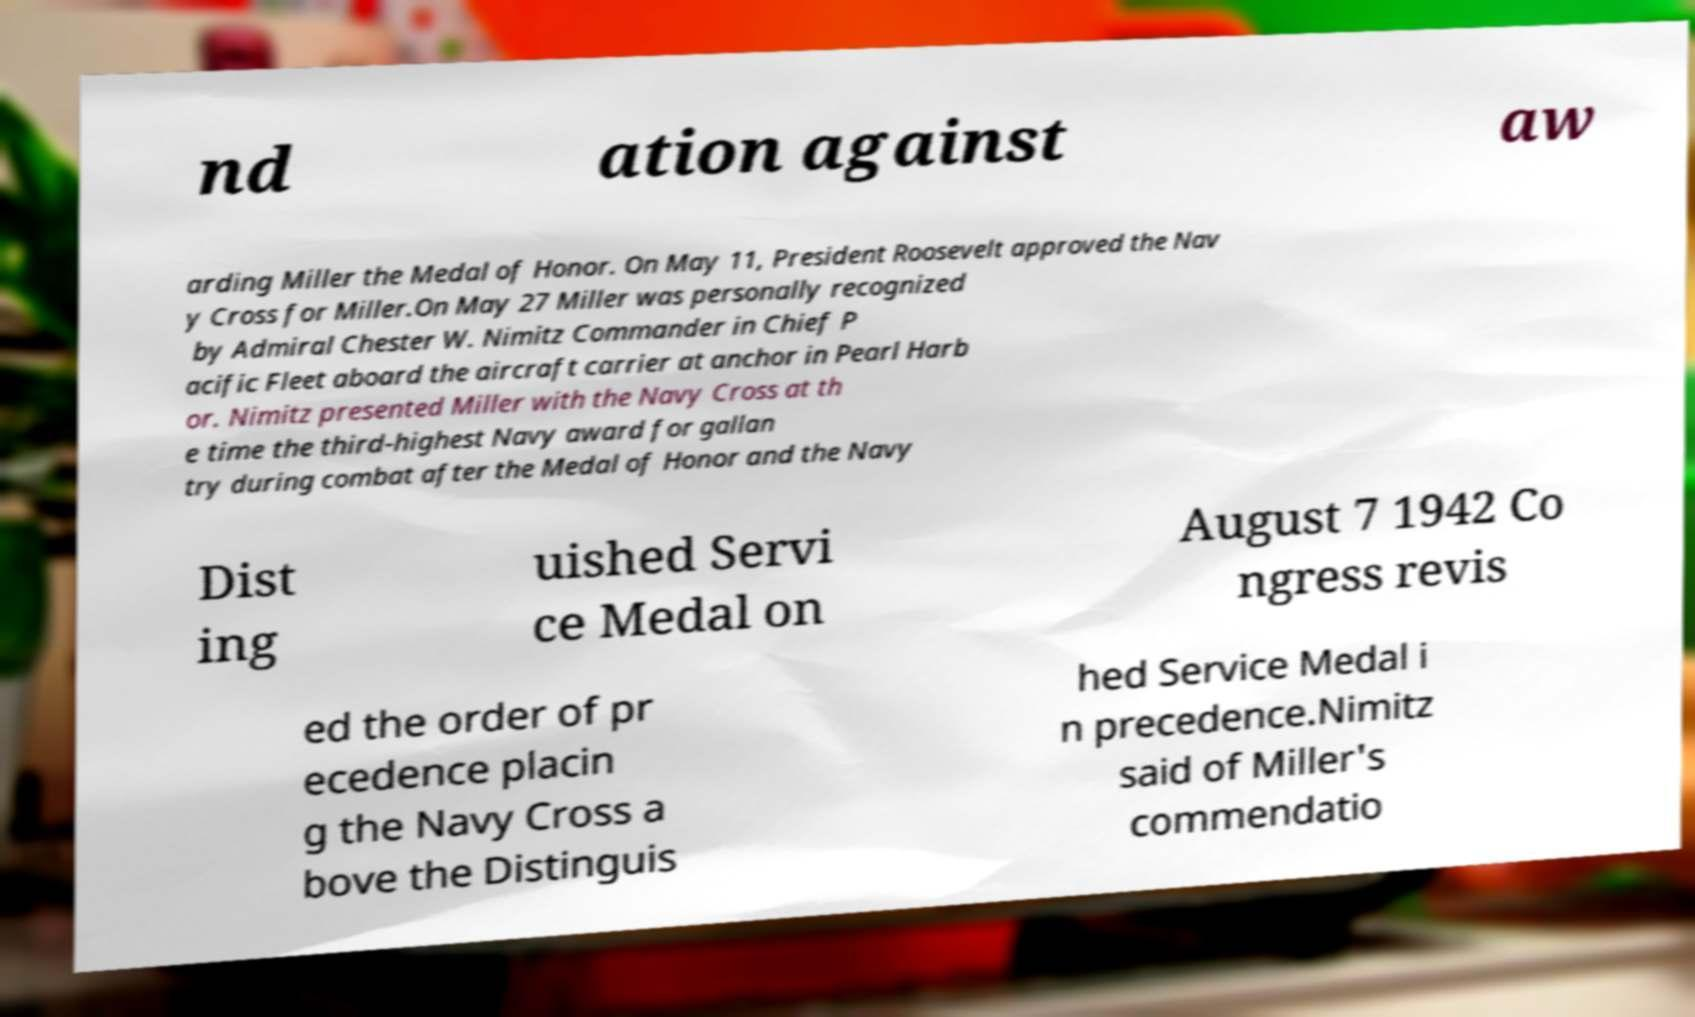Could you assist in decoding the text presented in this image and type it out clearly? nd ation against aw arding Miller the Medal of Honor. On May 11, President Roosevelt approved the Nav y Cross for Miller.On May 27 Miller was personally recognized by Admiral Chester W. Nimitz Commander in Chief P acific Fleet aboard the aircraft carrier at anchor in Pearl Harb or. Nimitz presented Miller with the Navy Cross at th e time the third-highest Navy award for gallan try during combat after the Medal of Honor and the Navy Dist ing uished Servi ce Medal on August 7 1942 Co ngress revis ed the order of pr ecedence placin g the Navy Cross a bove the Distinguis hed Service Medal i n precedence.Nimitz said of Miller's commendatio 